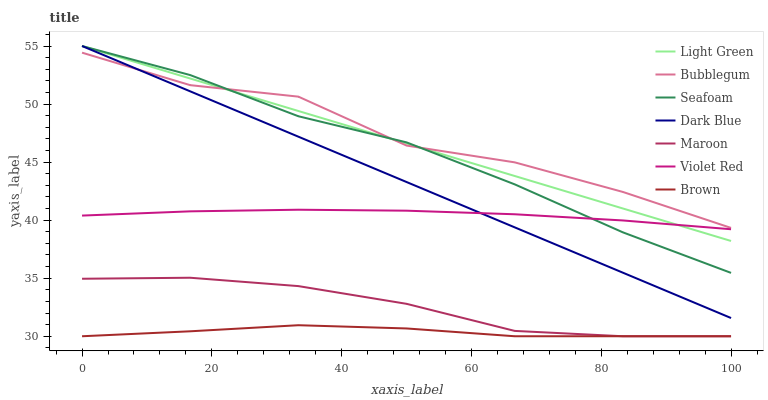Does Brown have the minimum area under the curve?
Answer yes or no. Yes. Does Bubblegum have the maximum area under the curve?
Answer yes or no. Yes. Does Violet Red have the minimum area under the curve?
Answer yes or no. No. Does Violet Red have the maximum area under the curve?
Answer yes or no. No. Is Light Green the smoothest?
Answer yes or no. Yes. Is Bubblegum the roughest?
Answer yes or no. Yes. Is Violet Red the smoothest?
Answer yes or no. No. Is Violet Red the roughest?
Answer yes or no. No. Does Brown have the lowest value?
Answer yes or no. Yes. Does Violet Red have the lowest value?
Answer yes or no. No. Does Light Green have the highest value?
Answer yes or no. Yes. Does Violet Red have the highest value?
Answer yes or no. No. Is Maroon less than Light Green?
Answer yes or no. Yes. Is Violet Red greater than Brown?
Answer yes or no. Yes. Does Violet Red intersect Seafoam?
Answer yes or no. Yes. Is Violet Red less than Seafoam?
Answer yes or no. No. Is Violet Red greater than Seafoam?
Answer yes or no. No. Does Maroon intersect Light Green?
Answer yes or no. No. 